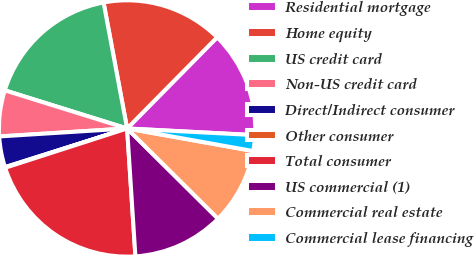Convert chart. <chart><loc_0><loc_0><loc_500><loc_500><pie_chart><fcel>Residential mortgage<fcel>Home equity<fcel>US credit card<fcel>Non-US credit card<fcel>Direct/Indirect consumer<fcel>Other consumer<fcel>Total consumer<fcel>US commercial (1)<fcel>Commercial real estate<fcel>Commercial lease financing<nl><fcel>13.43%<fcel>15.34%<fcel>17.25%<fcel>5.8%<fcel>3.89%<fcel>0.08%<fcel>21.07%<fcel>11.53%<fcel>9.62%<fcel>1.99%<nl></chart> 